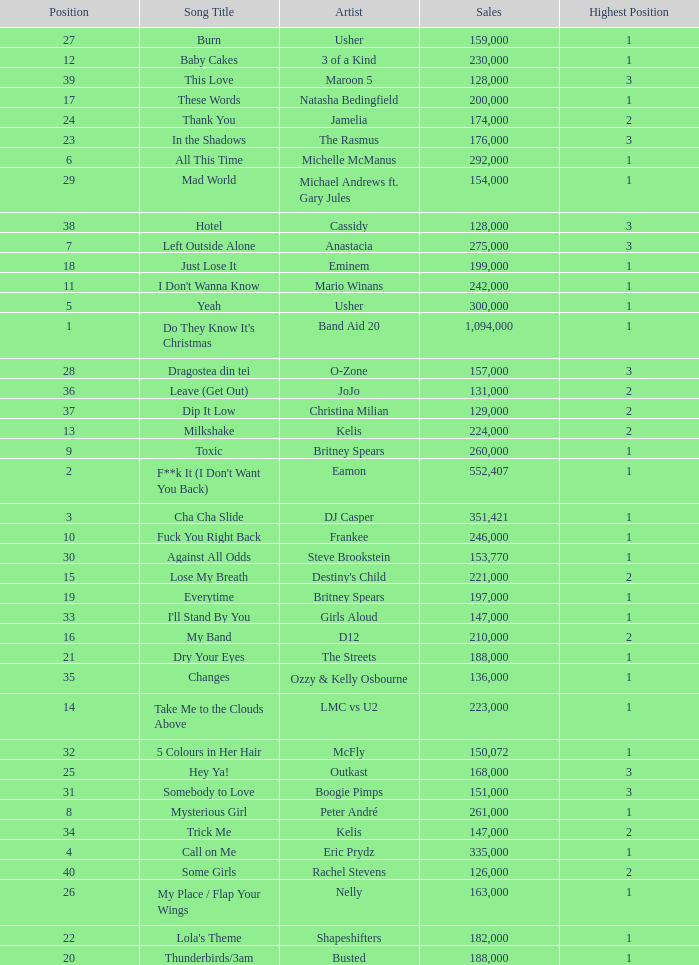Can you parse all the data within this table? {'header': ['Position', 'Song Title', 'Artist', 'Sales', 'Highest Position'], 'rows': [['27', 'Burn', 'Usher', '159,000', '1'], ['12', 'Baby Cakes', '3 of a Kind', '230,000', '1'], ['39', 'This Love', 'Maroon 5', '128,000', '3'], ['17', 'These Words', 'Natasha Bedingfield', '200,000', '1'], ['24', 'Thank You', 'Jamelia', '174,000', '2'], ['23', 'In the Shadows', 'The Rasmus', '176,000', '3'], ['6', 'All This Time', 'Michelle McManus', '292,000', '1'], ['29', 'Mad World', 'Michael Andrews ft. Gary Jules', '154,000', '1'], ['38', 'Hotel', 'Cassidy', '128,000', '3'], ['7', 'Left Outside Alone', 'Anastacia', '275,000', '3'], ['18', 'Just Lose It', 'Eminem', '199,000', '1'], ['11', "I Don't Wanna Know", 'Mario Winans', '242,000', '1'], ['5', 'Yeah', 'Usher', '300,000', '1'], ['1', "Do They Know It's Christmas", 'Band Aid 20', '1,094,000', '1'], ['28', 'Dragostea din tei', 'O-Zone', '157,000', '3'], ['36', 'Leave (Get Out)', 'JoJo', '131,000', '2'], ['37', 'Dip It Low', 'Christina Milian', '129,000', '2'], ['13', 'Milkshake', 'Kelis', '224,000', '2'], ['9', 'Toxic', 'Britney Spears', '260,000', '1'], ['2', "F**k It (I Don't Want You Back)", 'Eamon', '552,407', '1'], ['3', 'Cha Cha Slide', 'DJ Casper', '351,421', '1'], ['10', 'Fuck You Right Back', 'Frankee', '246,000', '1'], ['30', 'Against All Odds', 'Steve Brookstein', '153,770', '1'], ['15', 'Lose My Breath', "Destiny's Child", '221,000', '2'], ['19', 'Everytime', 'Britney Spears', '197,000', '1'], ['33', "I'll Stand By You", 'Girls Aloud', '147,000', '1'], ['16', 'My Band', 'D12', '210,000', '2'], ['21', 'Dry Your Eyes', 'The Streets', '188,000', '1'], ['35', 'Changes', 'Ozzy & Kelly Osbourne', '136,000', '1'], ['14', 'Take Me to the Clouds Above', 'LMC vs U2', '223,000', '1'], ['32', '5 Colours in Her Hair', 'McFly', '150,072', '1'], ['25', 'Hey Ya!', 'Outkast', '168,000', '3'], ['31', 'Somebody to Love', 'Boogie Pimps', '151,000', '3'], ['8', 'Mysterious Girl', 'Peter André', '261,000', '1'], ['34', 'Trick Me', 'Kelis', '147,000', '2'], ['4', 'Call on Me', 'Eric Prydz', '335,000', '1'], ['40', 'Some Girls', 'Rachel Stevens', '126,000', '2'], ['26', 'My Place / Flap Your Wings', 'Nelly', '163,000', '1'], ['22', "Lola's Theme", 'Shapeshifters', '182,000', '1'], ['20', 'Thunderbirds/3am', 'Busted', '188,000', '1']]} What were the sales for Dj Casper when he was in a position lower than 13? 351421.0. 